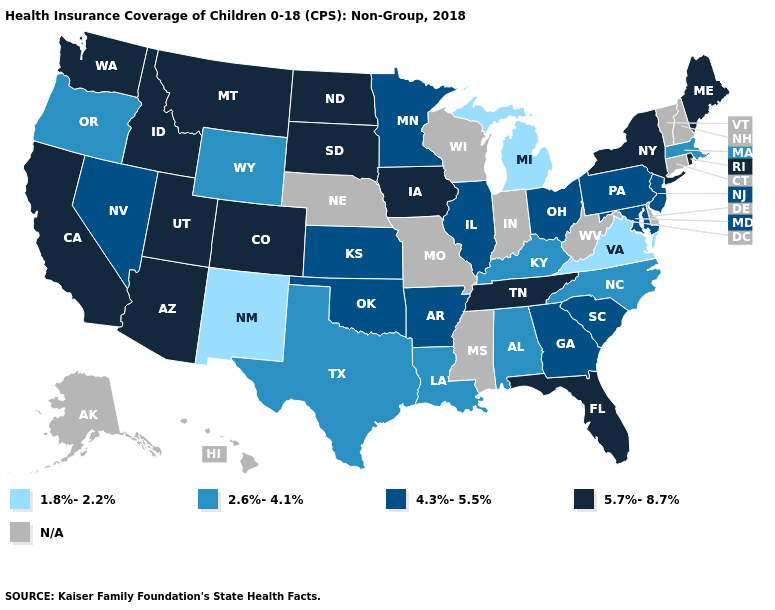Does New Mexico have the lowest value in the USA?
Be succinct. Yes. Among the states that border Arizona , which have the lowest value?
Write a very short answer. New Mexico. Name the states that have a value in the range 2.6%-4.1%?
Write a very short answer. Alabama, Kentucky, Louisiana, Massachusetts, North Carolina, Oregon, Texas, Wyoming. Does the map have missing data?
Concise answer only. Yes. Among the states that border South Carolina , which have the lowest value?
Give a very brief answer. North Carolina. What is the highest value in the USA?
Quick response, please. 5.7%-8.7%. Which states have the highest value in the USA?
Give a very brief answer. Arizona, California, Colorado, Florida, Idaho, Iowa, Maine, Montana, New York, North Dakota, Rhode Island, South Dakota, Tennessee, Utah, Washington. Does the map have missing data?
Short answer required. Yes. Which states have the lowest value in the USA?
Write a very short answer. Michigan, New Mexico, Virginia. What is the value of Oregon?
Write a very short answer. 2.6%-4.1%. Among the states that border Nebraska , which have the lowest value?
Answer briefly. Wyoming. Does Alabama have the highest value in the USA?
Answer briefly. No. What is the highest value in the USA?
Quick response, please. 5.7%-8.7%. What is the value of Kansas?
Short answer required. 4.3%-5.5%. 